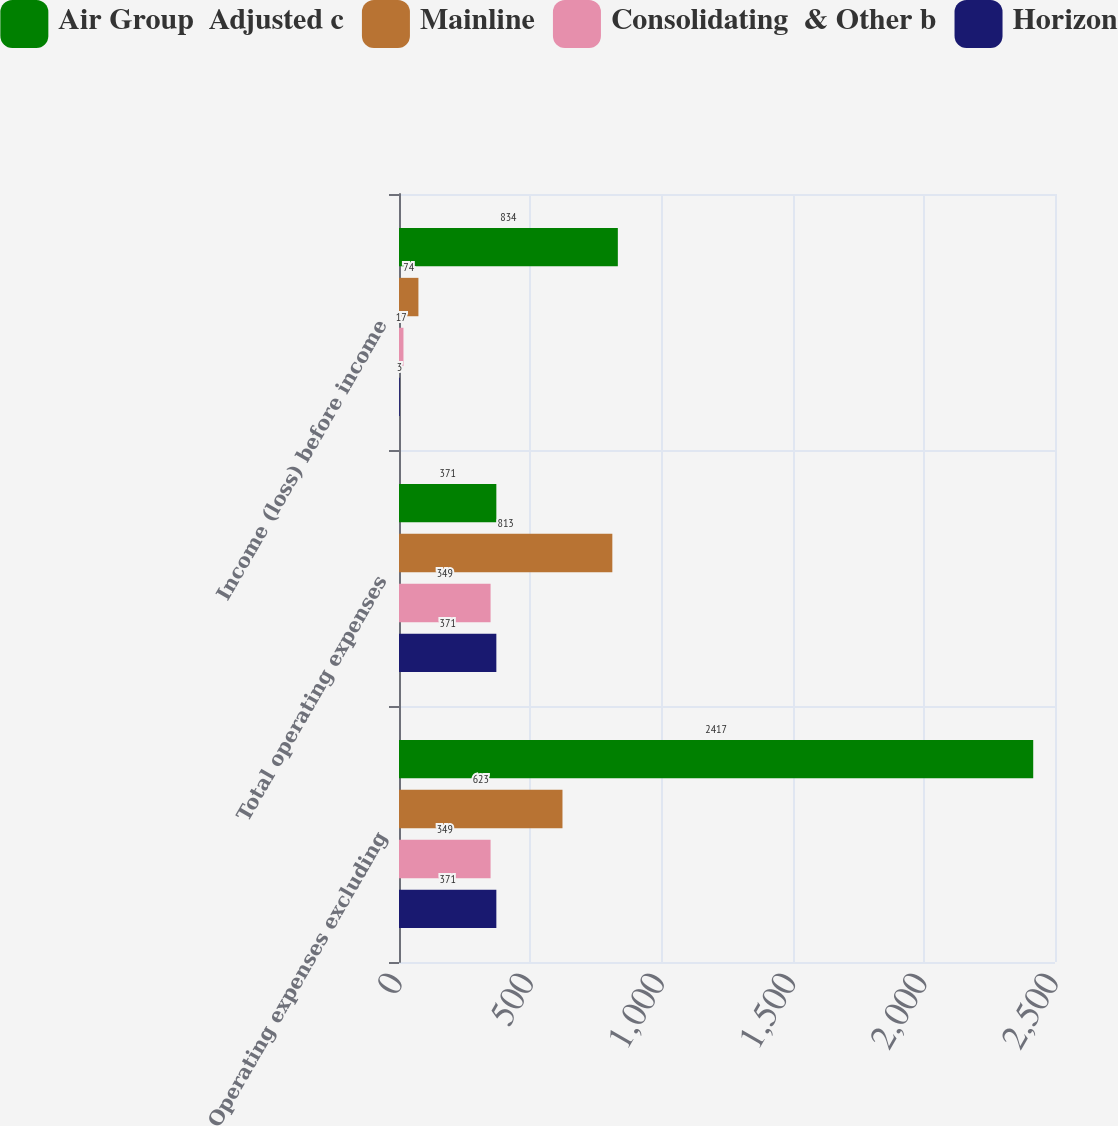<chart> <loc_0><loc_0><loc_500><loc_500><stacked_bar_chart><ecel><fcel>Operating expenses excluding<fcel>Total operating expenses<fcel>Income (loss) before income<nl><fcel>Air Group  Adjusted c<fcel>2417<fcel>371<fcel>834<nl><fcel>Mainline<fcel>623<fcel>813<fcel>74<nl><fcel>Consolidating  & Other b<fcel>349<fcel>349<fcel>17<nl><fcel>Horizon<fcel>371<fcel>371<fcel>3<nl></chart> 